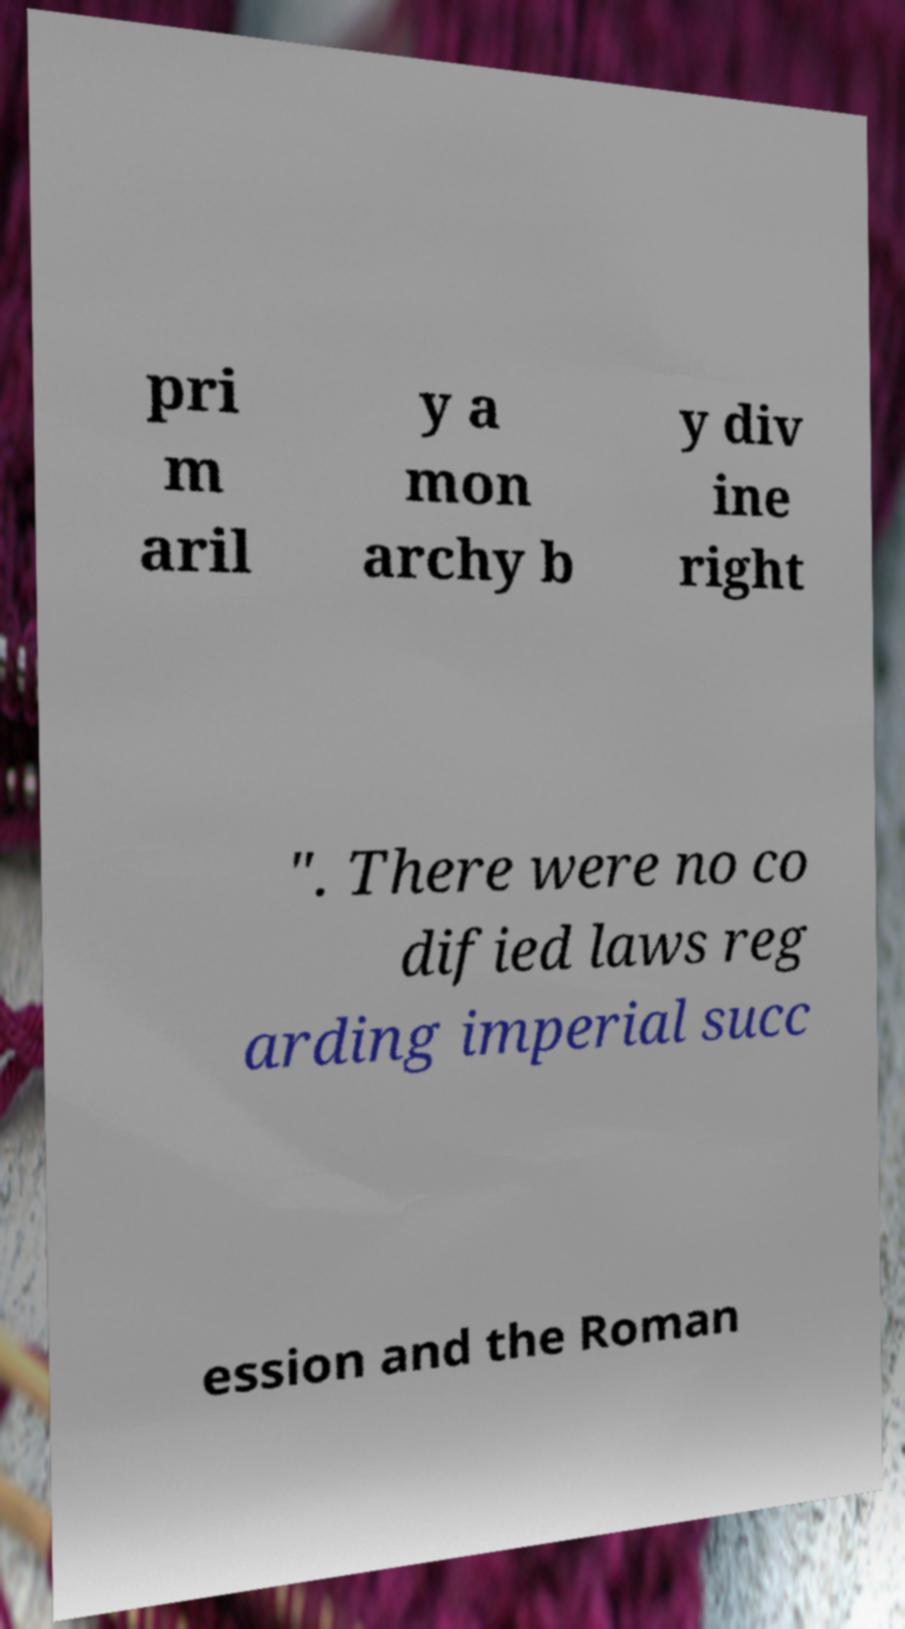There's text embedded in this image that I need extracted. Can you transcribe it verbatim? pri m aril y a mon archy b y div ine right ". There were no co dified laws reg arding imperial succ ession and the Roman 